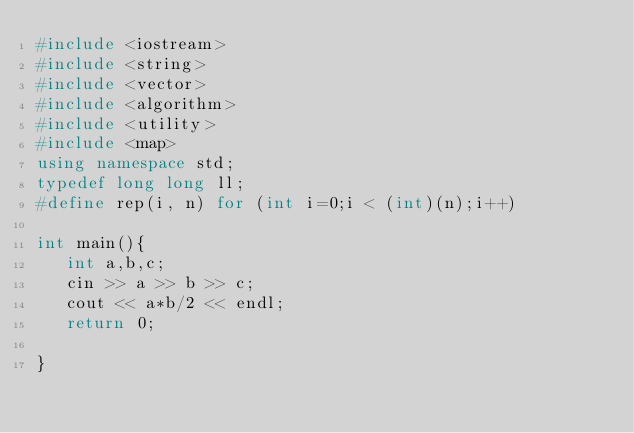Convert code to text. <code><loc_0><loc_0><loc_500><loc_500><_C++_>#include <iostream>
#include <string>
#include <vector>
#include <algorithm>
#include <utility>
#include <map>
using namespace std;
typedef long long ll;
#define rep(i, n) for (int i=0;i < (int)(n);i++)

int main(){
   int a,b,c;
   cin >> a >> b >> c;
   cout << a*b/2 << endl;
   return 0;
   
}

</code> 